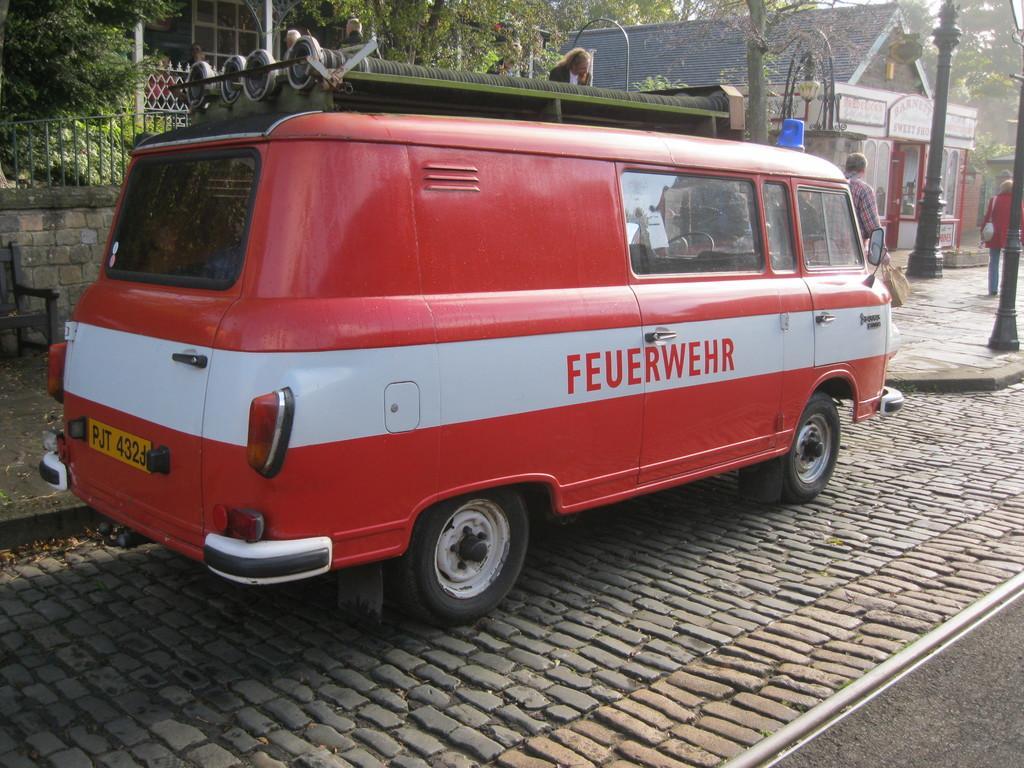Could you give a brief overview of what you see in this image? In this image we can see one house, one object on the top left side of the image, some objects in the house, few objects attached to the house, one light with pole, one pole, one fence, one board with text attached to the house, one person wearing a bag, one man holding a bag, few people in the background on the top left side of the image, few people are standing, two persons are sitting, one object looks like a chair on the left side of the image, some objects on the ground, some dried leaves on the ground, some trees in the background some objects on the vehicle, one vehicle on the road and one object looks like a railway track on the right side of the image. Some text and numbers on the vehicle. 